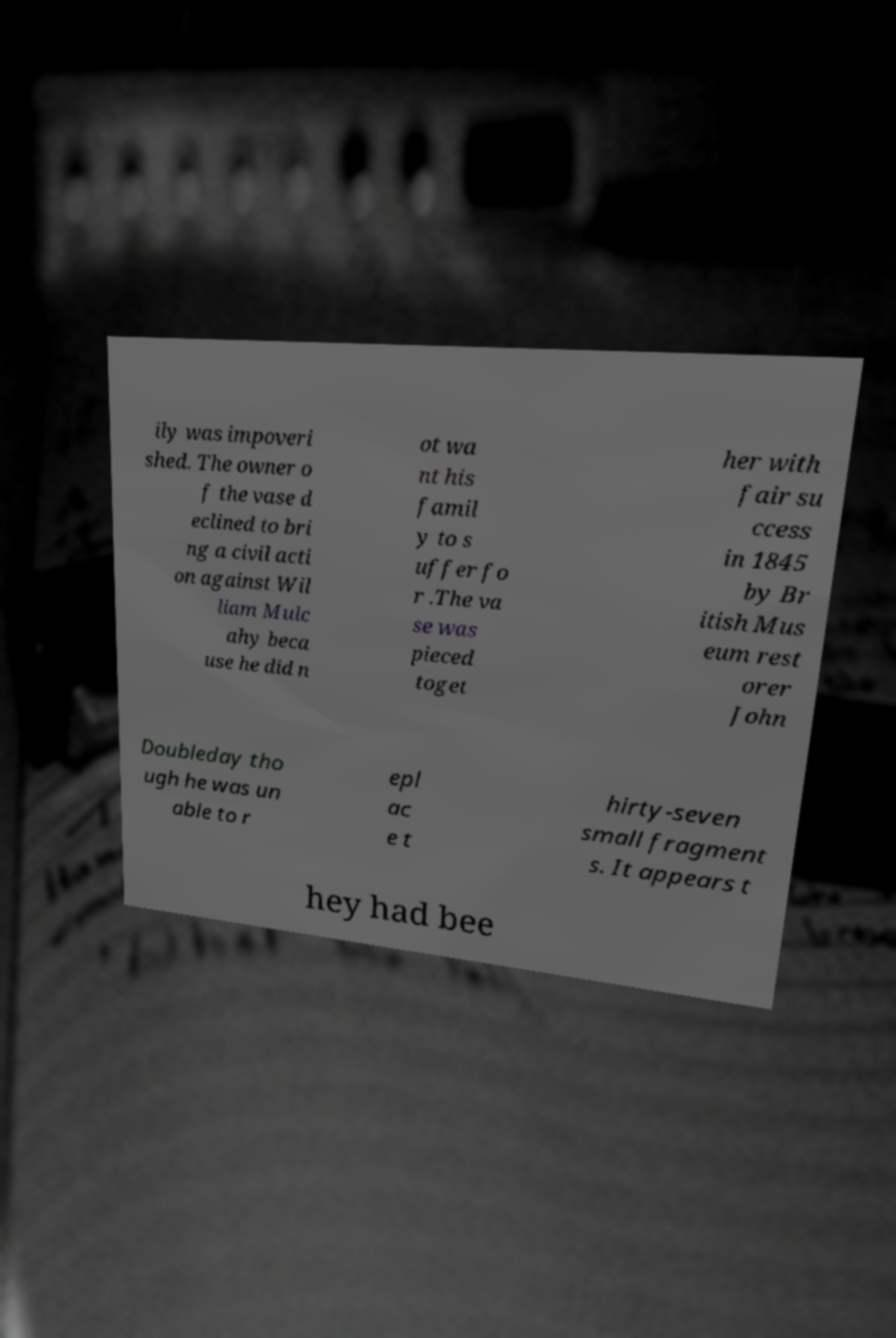Could you assist in decoding the text presented in this image and type it out clearly? ily was impoveri shed. The owner o f the vase d eclined to bri ng a civil acti on against Wil liam Mulc ahy beca use he did n ot wa nt his famil y to s uffer fo r .The va se was pieced toget her with fair su ccess in 1845 by Br itish Mus eum rest orer John Doubleday tho ugh he was un able to r epl ac e t hirty-seven small fragment s. It appears t hey had bee 